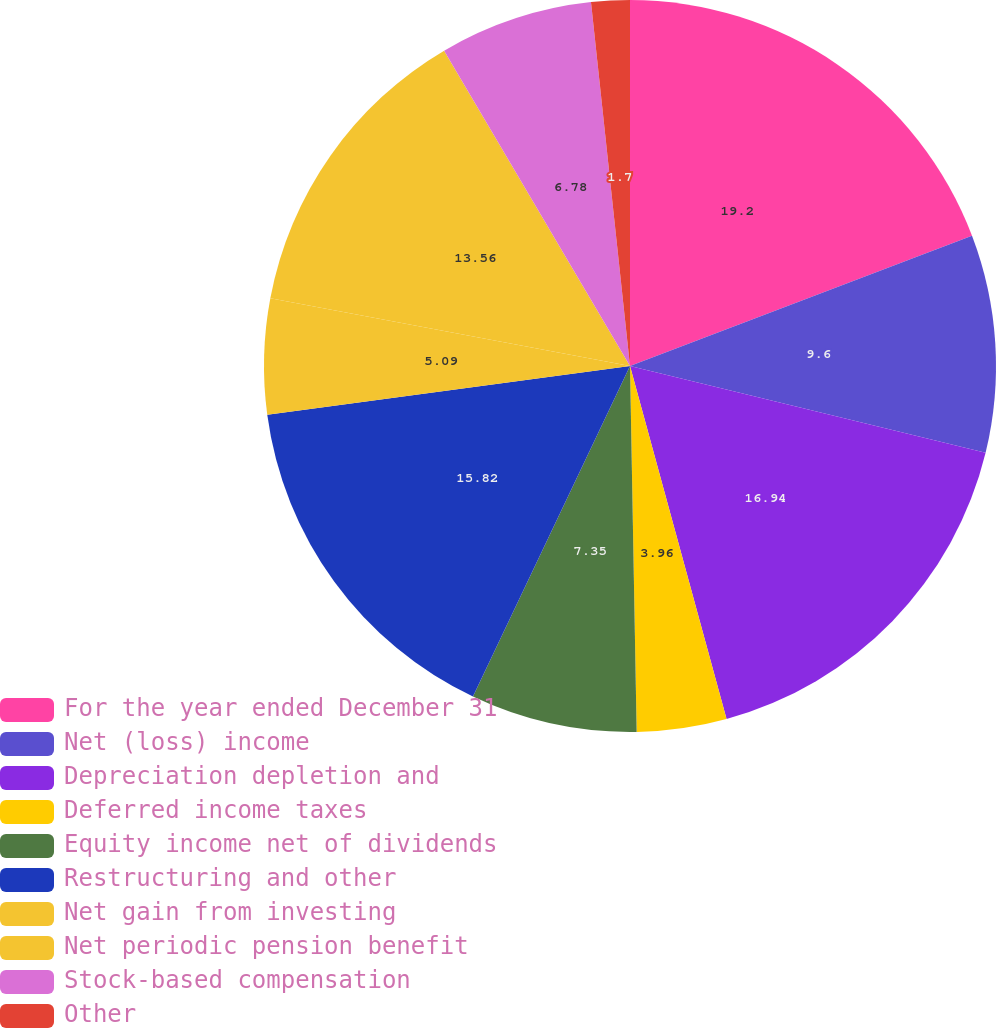<chart> <loc_0><loc_0><loc_500><loc_500><pie_chart><fcel>For the year ended December 31<fcel>Net (loss) income<fcel>Depreciation depletion and<fcel>Deferred income taxes<fcel>Equity income net of dividends<fcel>Restructuring and other<fcel>Net gain from investing<fcel>Net periodic pension benefit<fcel>Stock-based compensation<fcel>Other<nl><fcel>19.21%<fcel>9.6%<fcel>16.95%<fcel>3.96%<fcel>7.35%<fcel>15.82%<fcel>5.09%<fcel>13.56%<fcel>6.78%<fcel>1.7%<nl></chart> 